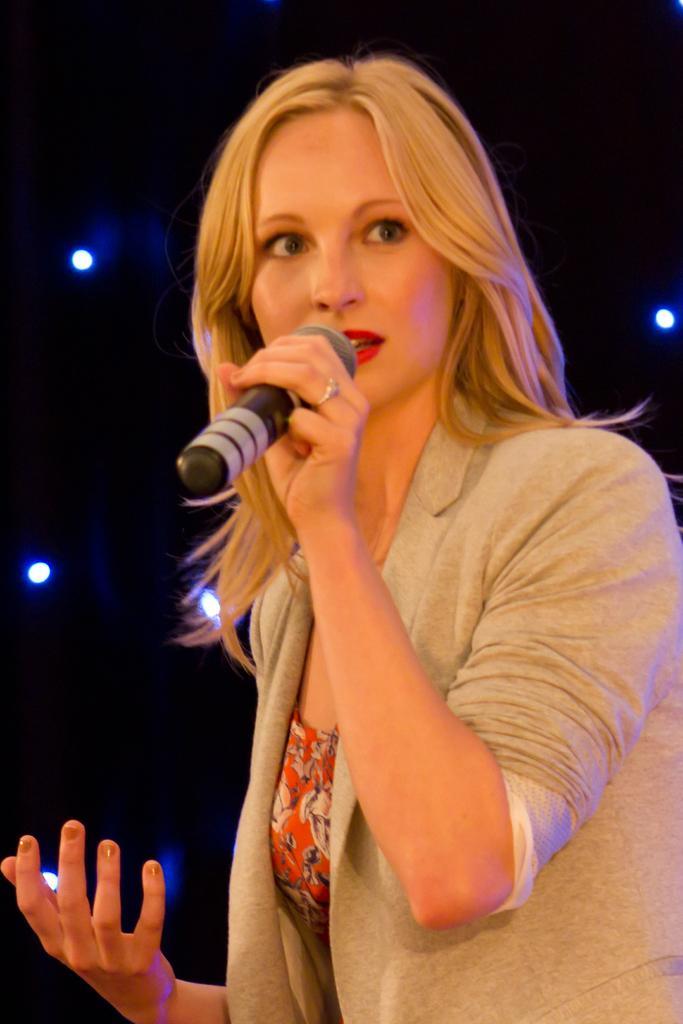How would you summarize this image in a sentence or two? In this image we can see a woman holding the mike. In the background, we can see the lights and the background is in black color. 